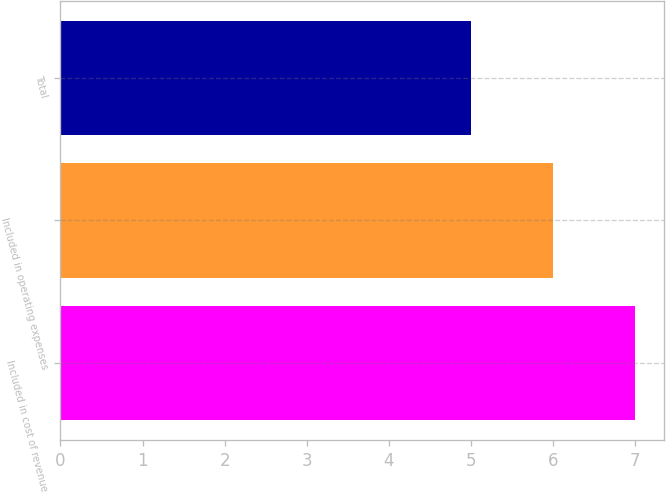Convert chart. <chart><loc_0><loc_0><loc_500><loc_500><bar_chart><fcel>Included in cost of revenue<fcel>Included in operating expenses<fcel>Total<nl><fcel>7<fcel>6<fcel>5<nl></chart> 